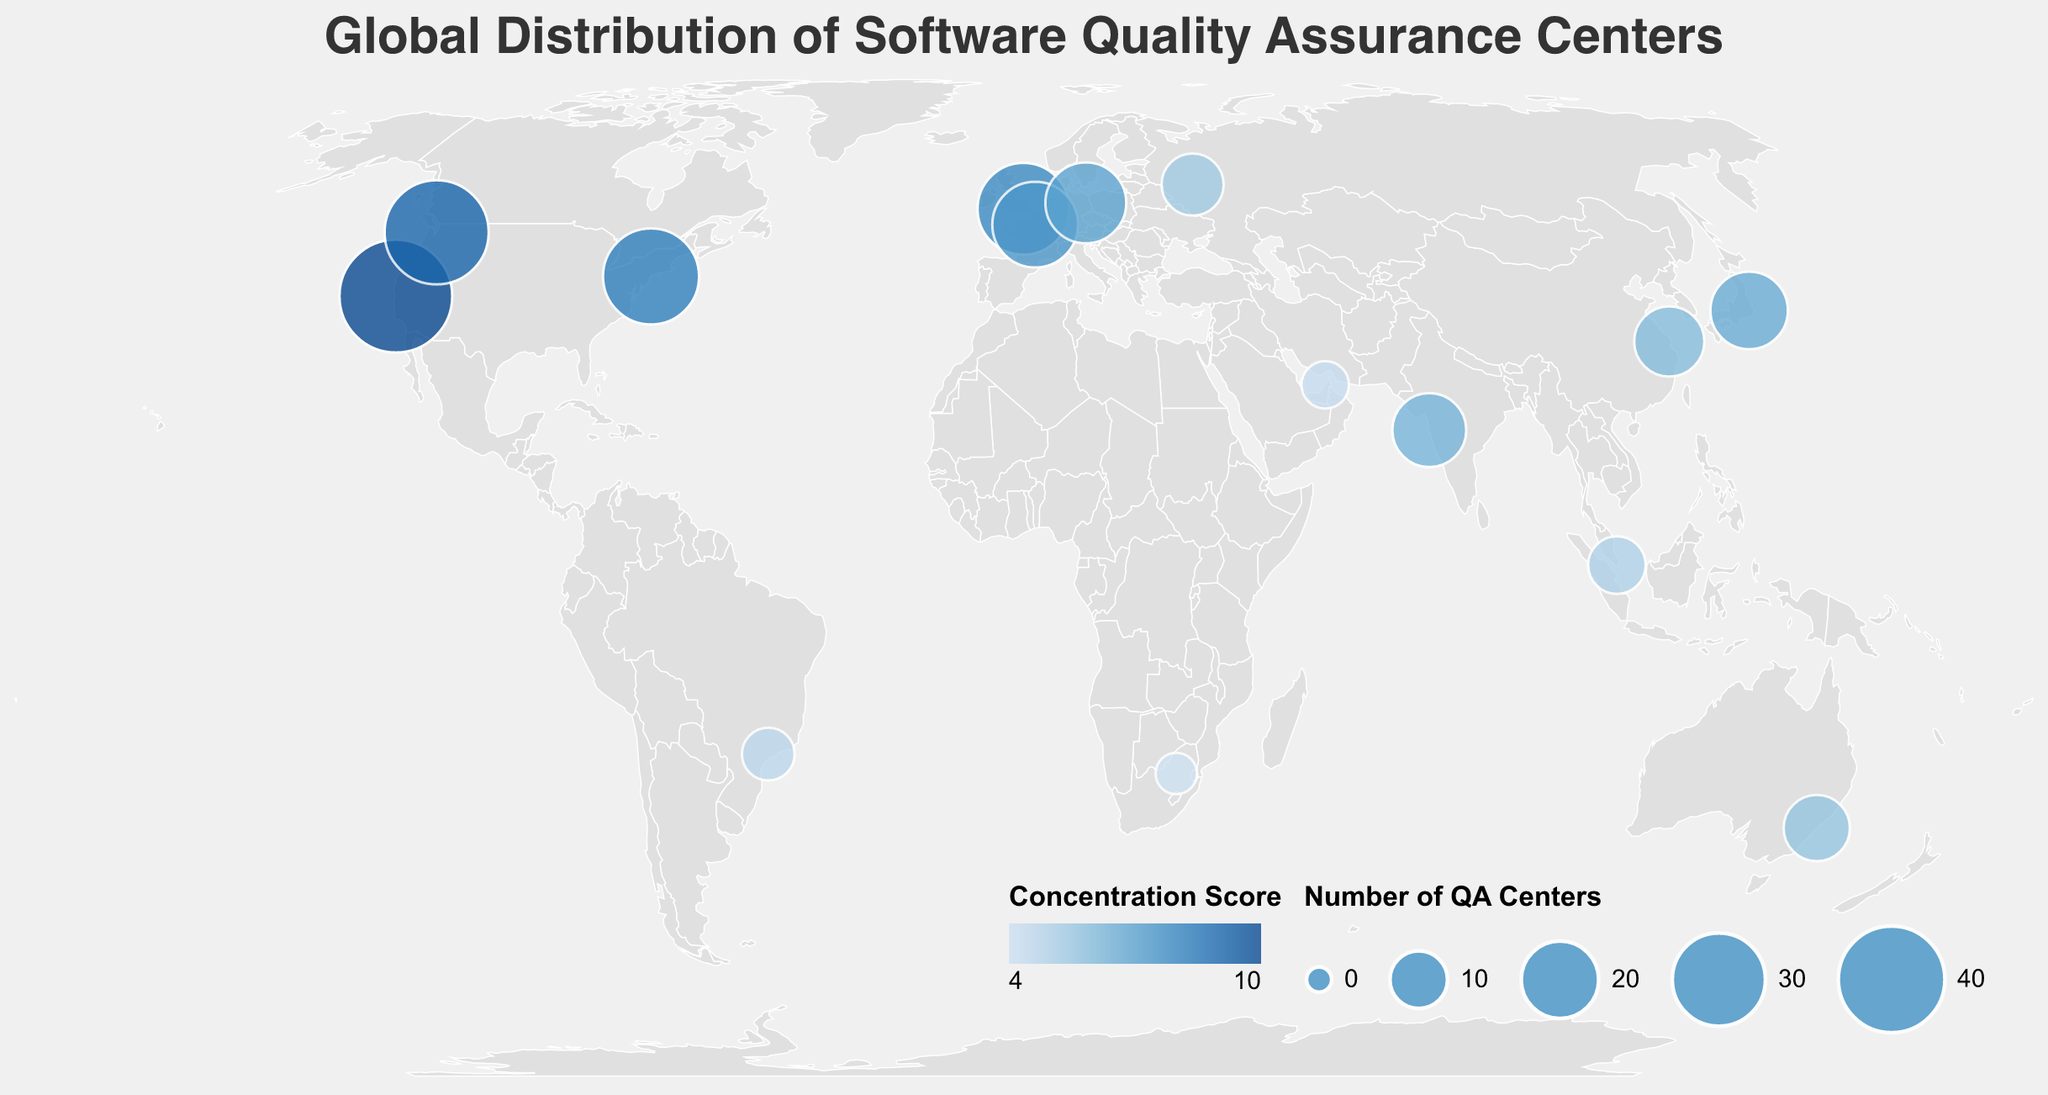What is the city with the highest number of QA centers? The figure highlights the number of QA centers for each city using the size of the circles. The largest circle indicates that San Francisco has the highest number of QA centers, which is 45.
Answer: San Francisco Which city has the highest concentration score? The concentration score for each city is shown in shades of blue, where the darkest shade represents the highest concentration score. San Francisco has the darkest shade with a concentration score of 9.5.
Answer: San Francisco How many QA centers are there in total across all cities shown? Sum up the number of QA centers from each city: 45 (San Francisco) + 38 (Seattle) + 32 (New York City) + 29 (London) + 25 (Paris) + 22 (Berlin) + 20 (Tokyo) + 18 (Mumbai) + 16 (Shanghai) + 14 (Sydney) + 12 (Moscow) + 10 (Singapore) + 8 (São Paulo) + 6 (Dubai) + 4 (Johannesburg) = 319 QA centers.
Answer: 319 Which two cities have the closest number of QA centers? To find the closest numbers, compare the QA centers for each pair of cities. The pairs Berlin (22) and Tokyo (20) have the smallest difference of 2.
Answer: Berlin and Tokyo What is the average concentration score across all cities? Add up all concentration scores and divide by the number of cities: (9.5 + 8.7 + 7.9 + 7.6 + 7.2 + 6.8 + 6.5 + 6.2 + 5.9 + 5.6 + 5.3 + 5.0 + 4.7 + 4.4 + 4.1) / 15 ≈ 6.40.
Answer: 6.40 How many cities have more than 20 QA centers? Name them. By inspecting the figure, cities with more than 20 QA centers are San Francisco (45), Seattle (38), New York City (32), London (29), Paris (25), and Berlin (22).
Answer: 6 cities: San Francisco, Seattle, New York City, London, Paris, Berlin Compare the total number of QA centers between the USA and Europe shown in the figure. Which has more? Sum up QA centers in the USA: San Francisco (45) + Seattle (38) + New York City (32) = 115. Sum up QA centers in Europe: London (29) + Paris (25) + Berlin (22) = 76. The USA has more QA centers.
Answer: USA Which city in Asia has the highest concentration score? The cities in Asia are Tokyo, Mumbai, Shanghai, and Singapore. Tokyo has the highest concentration score among them, which is 6.5.
Answer: Tokyo What is the combined concentration score for cities in the Southern Hemisphere? The Southern Hemisphere cities are Sydney, São Paulo, and Johannesburg. The combined concentration score is 5.6 (Sydney) + 4.7 (São Paulo) + 4.1 (Johannesburg) = 14.4.
Answer: 14.4 Which city has the lowest number of QA centers and what is its concentration score? The figure shows that Johannesburg has the smallest circle, indicating the lowest number of QA centers, which is 4. Its concentration score is 4.1.
Answer: Johannesburg, 4.1 